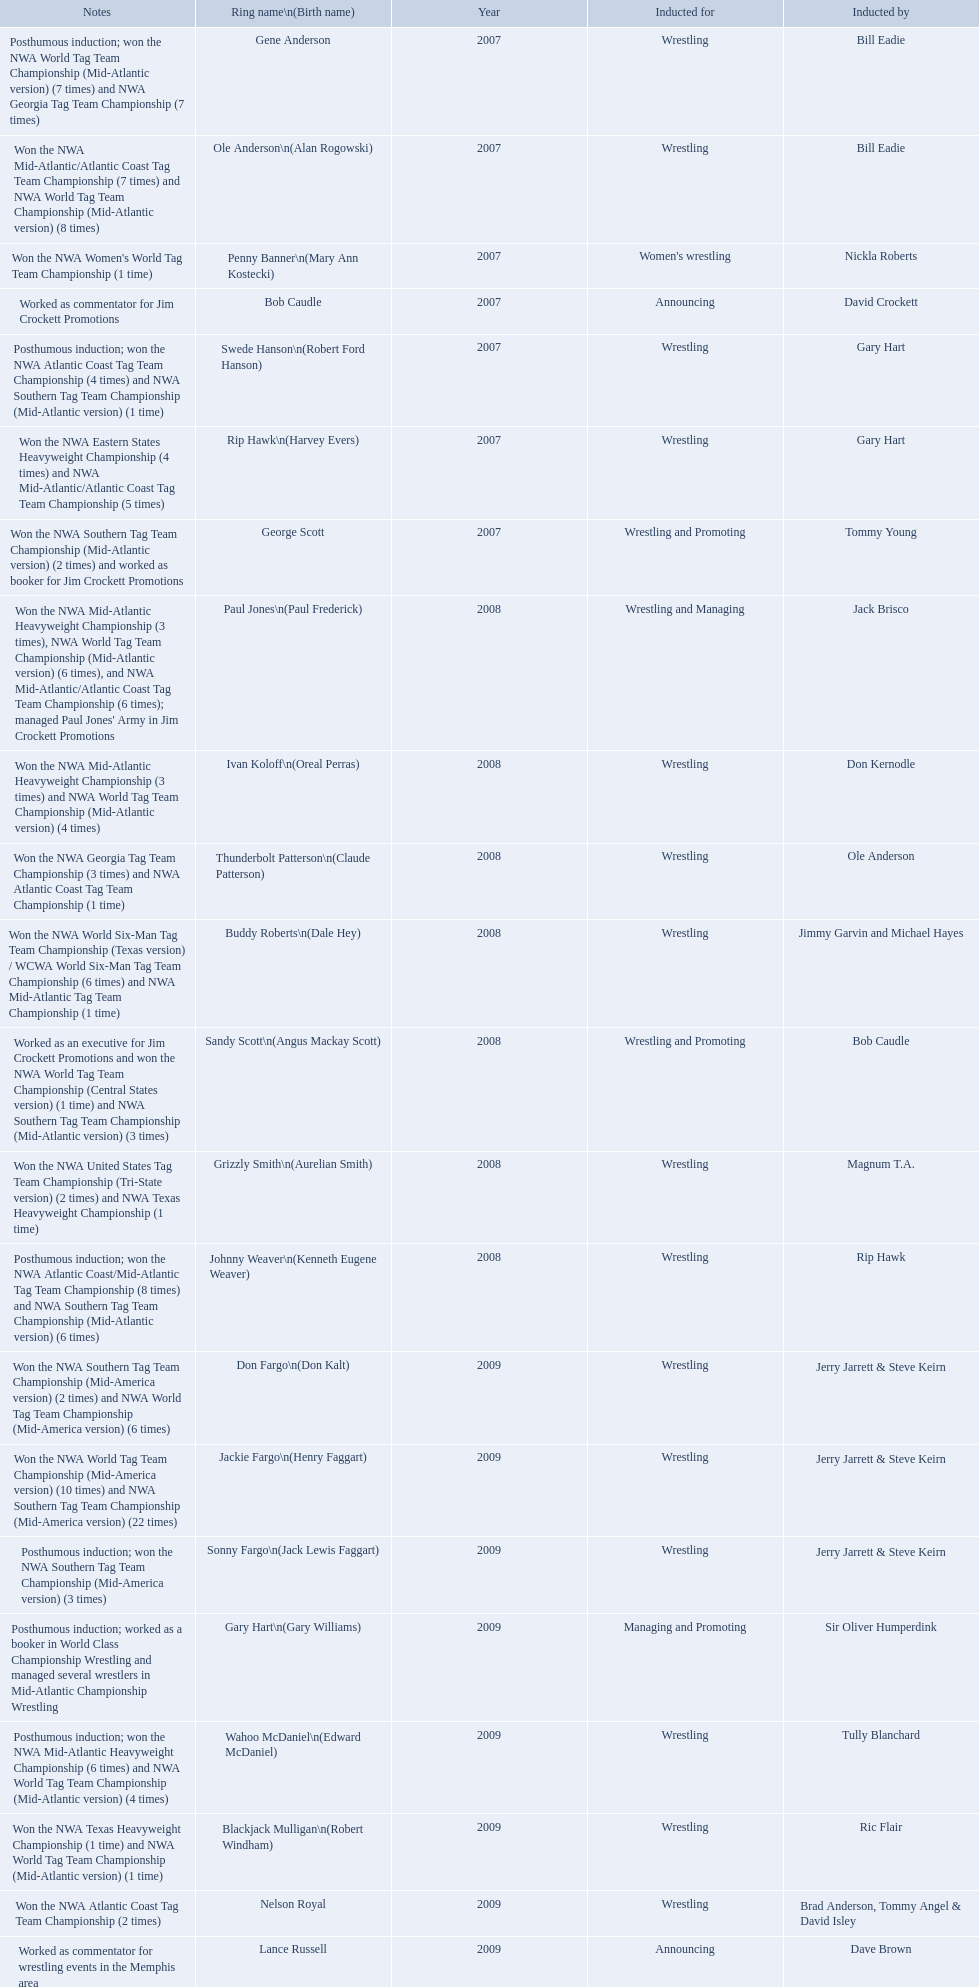What were the names of the inductees in 2007? Gene Anderson, Ole Anderson\n(Alan Rogowski), Penny Banner\n(Mary Ann Kostecki), Bob Caudle, Swede Hanson\n(Robert Ford Hanson), Rip Hawk\n(Harvey Evers), George Scott. Of the 2007 inductees, which were posthumous? Gene Anderson, Swede Hanson\n(Robert Ford Hanson). Besides swede hanson, what other 2007 inductee was not living at the time of induction? Gene Anderson. 